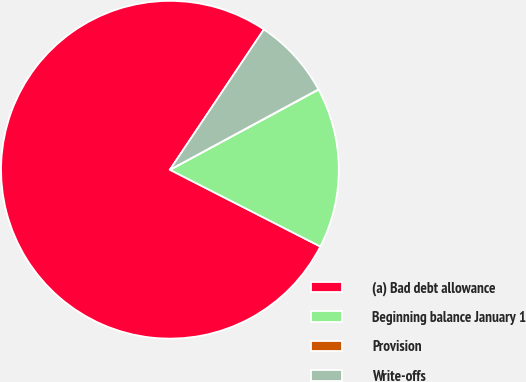Convert chart to OTSL. <chart><loc_0><loc_0><loc_500><loc_500><pie_chart><fcel>(a) Bad debt allowance<fcel>Beginning balance January 1<fcel>Provision<fcel>Write-offs<nl><fcel>76.88%<fcel>15.39%<fcel>0.02%<fcel>7.71%<nl></chart> 